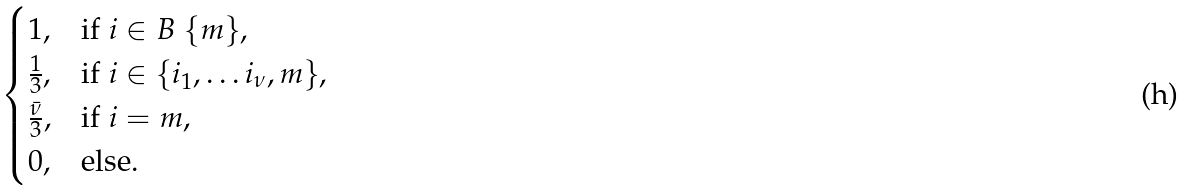Convert formula to latex. <formula><loc_0><loc_0><loc_500><loc_500>\begin{cases} 1 , & \text {if } i \in B \ \{ m \} , \\ \frac { 1 } { 3 } , & \text {if } i \in \{ i _ { 1 } , \dots i _ { \nu } , m \} , \\ \frac { \bar { \nu } } 3 , & \text {if } i = m , \\ 0 , & \text {else.} \end{cases}</formula> 